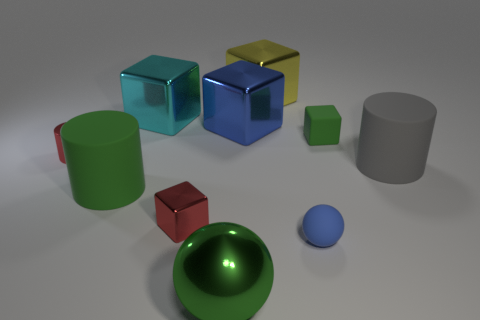Subtract all yellow cubes. How many cubes are left? 4 Subtract all matte blocks. How many blocks are left? 4 Subtract all purple blocks. Subtract all green cylinders. How many blocks are left? 5 Subtract all spheres. How many objects are left? 8 Subtract all purple metal blocks. Subtract all large blue metal objects. How many objects are left? 9 Add 2 yellow metallic blocks. How many yellow metallic blocks are left? 3 Add 7 small blue objects. How many small blue objects exist? 8 Subtract 1 green cylinders. How many objects are left? 9 